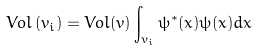Convert formula to latex. <formula><loc_0><loc_0><loc_500><loc_500>V o l \left ( v _ { i } \right ) = V o l ( v ) \int _ { v _ { i } } \psi ^ { * } ( x ) \psi ( x ) d x</formula> 